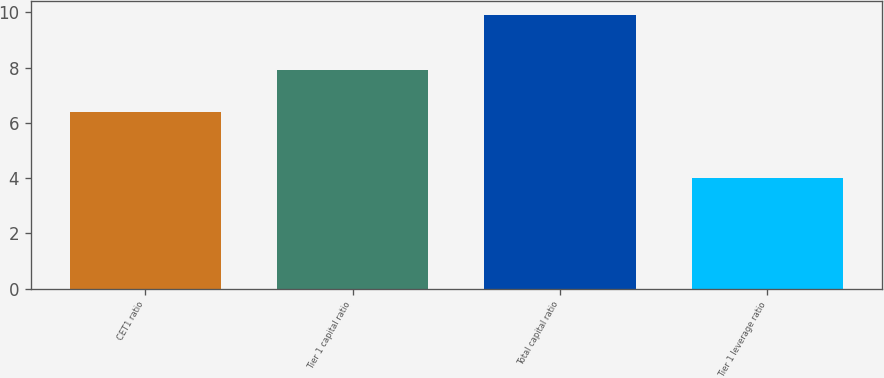Convert chart. <chart><loc_0><loc_0><loc_500><loc_500><bar_chart><fcel>CET1 ratio<fcel>Tier 1 capital ratio<fcel>Total capital ratio<fcel>Tier 1 leverage ratio<nl><fcel>6.4<fcel>7.9<fcel>9.9<fcel>4<nl></chart> 